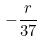<formula> <loc_0><loc_0><loc_500><loc_500>- \frac { r } { 3 7 }</formula> 